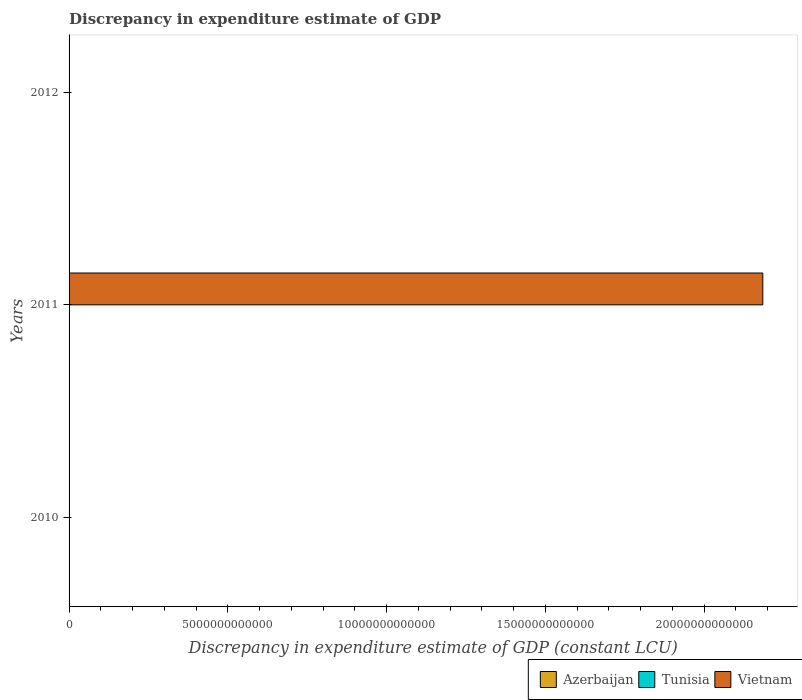Are the number of bars per tick equal to the number of legend labels?
Offer a very short reply. No. What is the label of the 3rd group of bars from the top?
Your response must be concise. 2010. Across all years, what is the maximum discrepancy in expenditure estimate of GDP in Vietnam?
Provide a short and direct response. 2.18e+13. Across all years, what is the minimum discrepancy in expenditure estimate of GDP in Tunisia?
Offer a terse response. 0. In which year was the discrepancy in expenditure estimate of GDP in Vietnam maximum?
Your response must be concise. 2011. What is the difference between the discrepancy in expenditure estimate of GDP in Tunisia in 2010 and the discrepancy in expenditure estimate of GDP in Vietnam in 2011?
Make the answer very short. -2.18e+13. What is the average discrepancy in expenditure estimate of GDP in Vietnam per year?
Your answer should be very brief. 7.28e+12. In how many years, is the discrepancy in expenditure estimate of GDP in Azerbaijan greater than 14000000000000 LCU?
Offer a very short reply. 0. What is the difference between the highest and the lowest discrepancy in expenditure estimate of GDP in Vietnam?
Your answer should be very brief. 2.18e+13. How many bars are there?
Keep it short and to the point. 1. What is the difference between two consecutive major ticks on the X-axis?
Offer a very short reply. 5.00e+12. Are the values on the major ticks of X-axis written in scientific E-notation?
Offer a very short reply. No. Does the graph contain any zero values?
Ensure brevity in your answer.  Yes. Does the graph contain grids?
Offer a terse response. No. How are the legend labels stacked?
Ensure brevity in your answer.  Horizontal. What is the title of the graph?
Keep it short and to the point. Discrepancy in expenditure estimate of GDP. Does "Kenya" appear as one of the legend labels in the graph?
Keep it short and to the point. No. What is the label or title of the X-axis?
Give a very brief answer. Discrepancy in expenditure estimate of GDP (constant LCU). What is the label or title of the Y-axis?
Offer a terse response. Years. What is the Discrepancy in expenditure estimate of GDP (constant LCU) of Azerbaijan in 2010?
Provide a succinct answer. 0. What is the Discrepancy in expenditure estimate of GDP (constant LCU) in Tunisia in 2010?
Your response must be concise. 0. What is the Discrepancy in expenditure estimate of GDP (constant LCU) in Vietnam in 2010?
Make the answer very short. 0. What is the Discrepancy in expenditure estimate of GDP (constant LCU) of Azerbaijan in 2011?
Your answer should be compact. 0. What is the Discrepancy in expenditure estimate of GDP (constant LCU) of Vietnam in 2011?
Offer a very short reply. 2.18e+13. What is the Discrepancy in expenditure estimate of GDP (constant LCU) in Tunisia in 2012?
Make the answer very short. 0. What is the Discrepancy in expenditure estimate of GDP (constant LCU) in Vietnam in 2012?
Keep it short and to the point. 0. Across all years, what is the maximum Discrepancy in expenditure estimate of GDP (constant LCU) in Vietnam?
Your answer should be very brief. 2.18e+13. Across all years, what is the minimum Discrepancy in expenditure estimate of GDP (constant LCU) of Vietnam?
Offer a very short reply. 0. What is the total Discrepancy in expenditure estimate of GDP (constant LCU) of Azerbaijan in the graph?
Your response must be concise. 0. What is the total Discrepancy in expenditure estimate of GDP (constant LCU) in Tunisia in the graph?
Ensure brevity in your answer.  0. What is the total Discrepancy in expenditure estimate of GDP (constant LCU) of Vietnam in the graph?
Provide a short and direct response. 2.18e+13. What is the average Discrepancy in expenditure estimate of GDP (constant LCU) in Azerbaijan per year?
Keep it short and to the point. 0. What is the average Discrepancy in expenditure estimate of GDP (constant LCU) of Vietnam per year?
Keep it short and to the point. 7.28e+12. What is the difference between the highest and the lowest Discrepancy in expenditure estimate of GDP (constant LCU) of Vietnam?
Ensure brevity in your answer.  2.18e+13. 